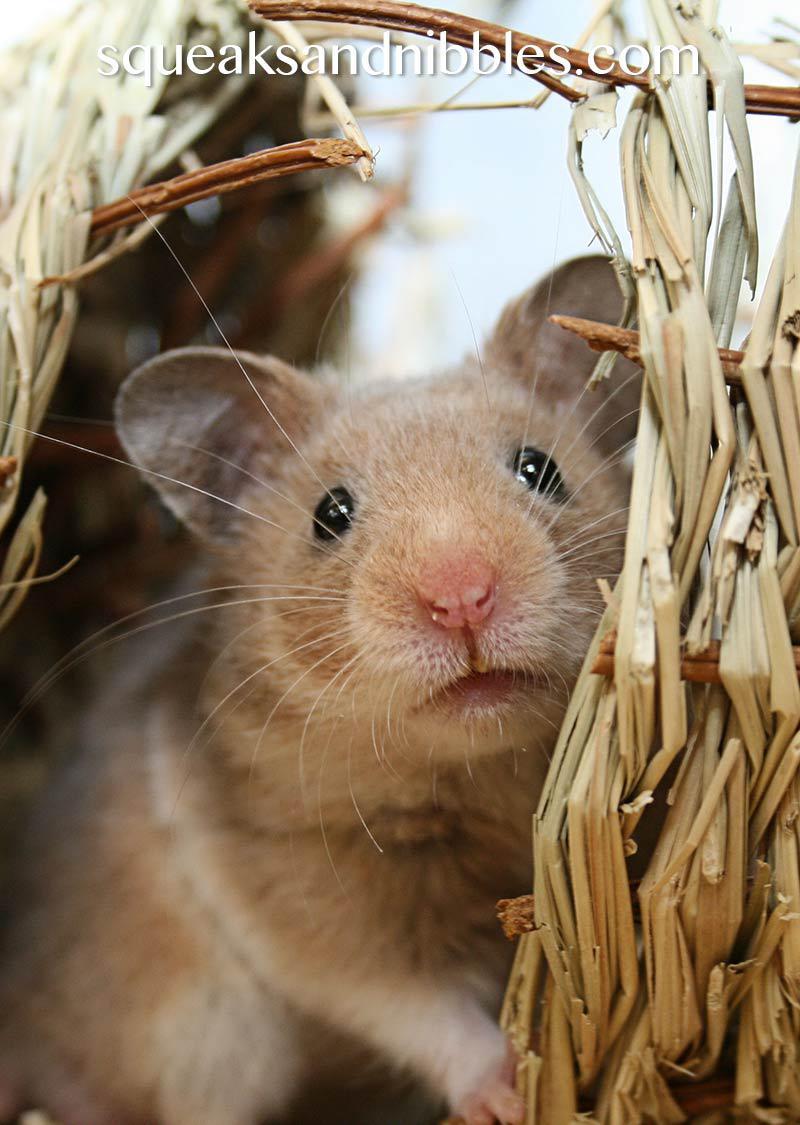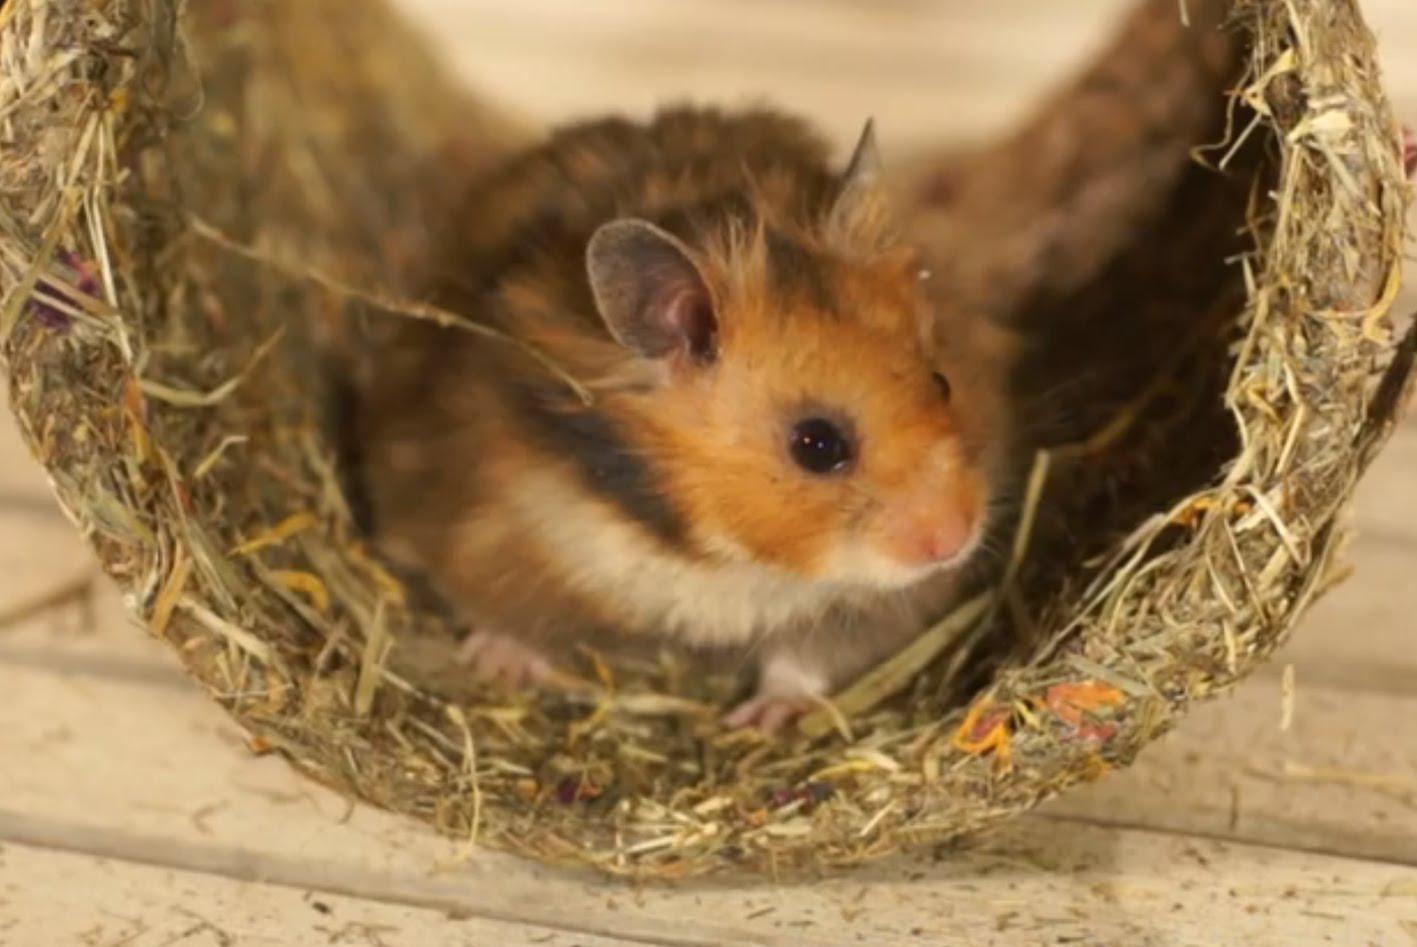The first image is the image on the left, the second image is the image on the right. Considering the images on both sides, is "There is a single animal in one image and at least two animals in the other." valid? Answer yes or no. No. The first image is the image on the left, the second image is the image on the right. For the images shown, is this caption "There are 3 hamsters in the image pair" true? Answer yes or no. No. 